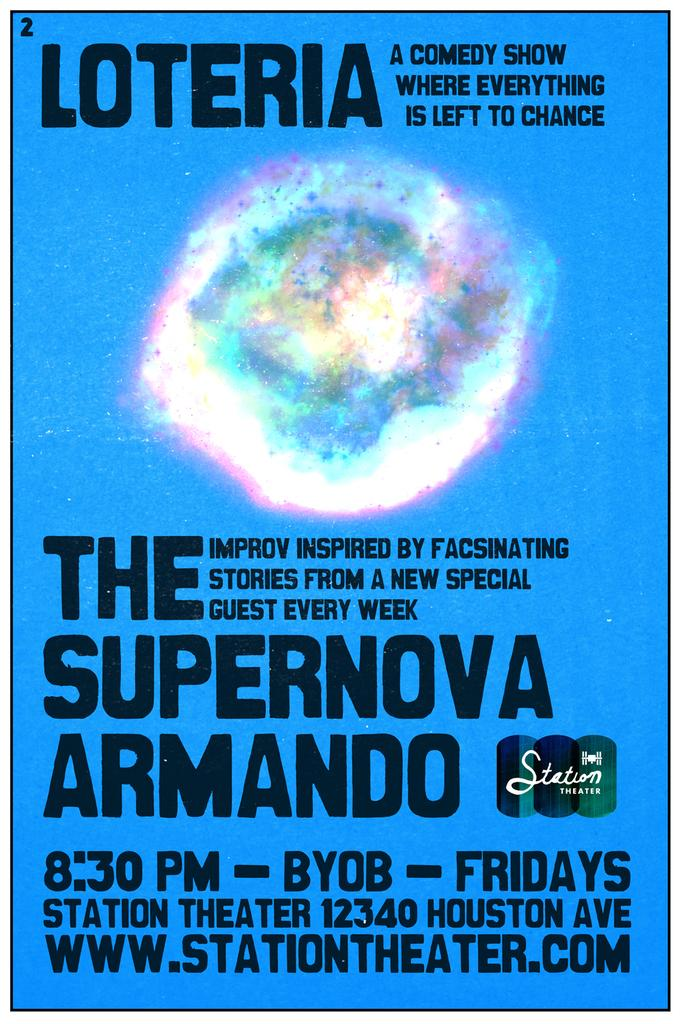What color is the poster in the image? The poster is blue in color. What can be seen written on the poster? There are black letters on the poster. What type of image is depicted on the poster? The poster is a picture. How many clouds are depicted in the picture on the poster? There are no clouds depicted in the picture on the poster; it is a blue poster with black letters. Can you see a guitar in the picture on the poster? There is no guitar present in the picture on the poster. 